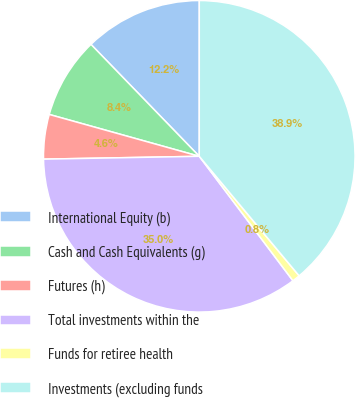Convert chart to OTSL. <chart><loc_0><loc_0><loc_500><loc_500><pie_chart><fcel>International Equity (b)<fcel>Cash and Cash Equivalents (g)<fcel>Futures (h)<fcel>Total investments within the<fcel>Funds for retiree health<fcel>Investments (excluding funds<nl><fcel>12.24%<fcel>8.43%<fcel>4.62%<fcel>34.97%<fcel>0.81%<fcel>38.91%<nl></chart> 